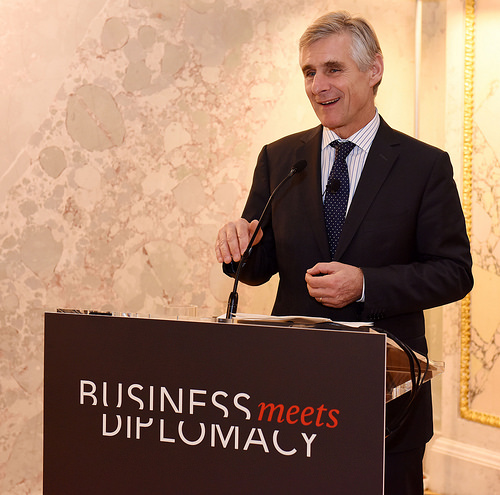<image>
Is there a mic to the right of the man? No. The mic is not to the right of the man. The horizontal positioning shows a different relationship. 